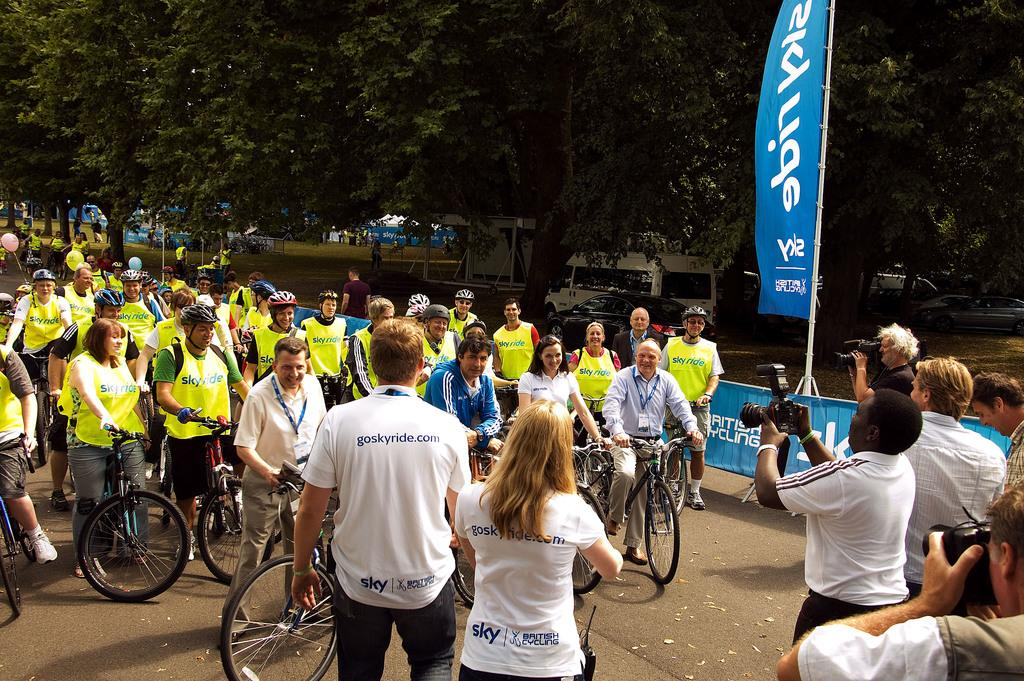What are the people in the image doing? The people in the image are riding bicycles. Are there any other people in the image? Yes, there are other people in front of the cyclists. What are these people holding? These people are holding cameras. How many cats can be seen in the image? There are no cats present in the image. What type of spot is visible on the bicycles in the image? There is no mention of any spots on the bicycles in the image. 